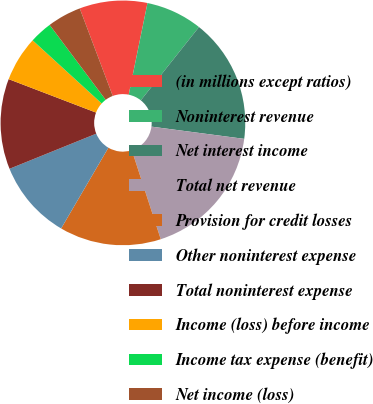Convert chart to OTSL. <chart><loc_0><loc_0><loc_500><loc_500><pie_chart><fcel>(in millions except ratios)<fcel>Noninterest revenue<fcel>Net interest income<fcel>Total net revenue<fcel>Provision for credit losses<fcel>Other noninterest expense<fcel>Total noninterest expense<fcel>Income (loss) before income<fcel>Income tax expense (benefit)<fcel>Net income (loss)<nl><fcel>8.96%<fcel>7.46%<fcel>16.41%<fcel>17.91%<fcel>13.43%<fcel>10.45%<fcel>11.94%<fcel>5.97%<fcel>2.99%<fcel>4.48%<nl></chart> 